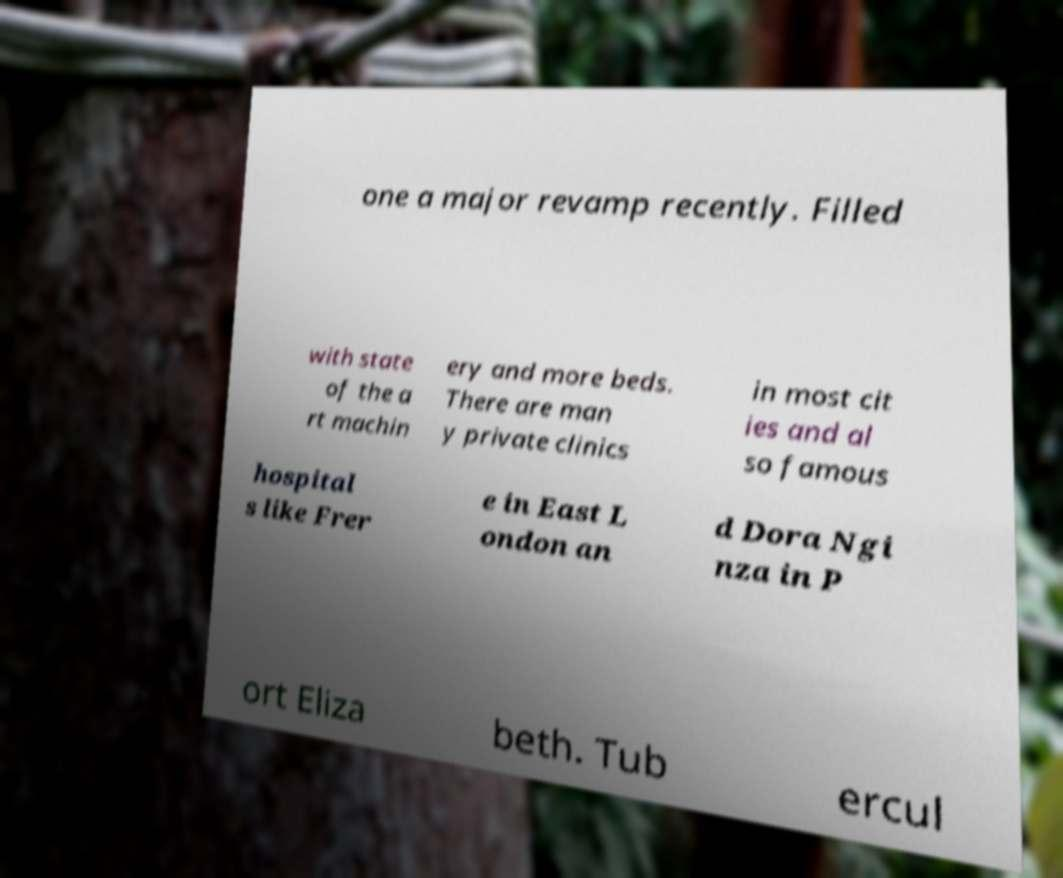Can you accurately transcribe the text from the provided image for me? one a major revamp recently. Filled with state of the a rt machin ery and more beds. There are man y private clinics in most cit ies and al so famous hospital s like Frer e in East L ondon an d Dora Ngi nza in P ort Eliza beth. Tub ercul 